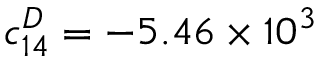Convert formula to latex. <formula><loc_0><loc_0><loc_500><loc_500>c _ { 1 4 } ^ { D } = - 5 . 4 6 \times 1 0 ^ { 3 }</formula> 